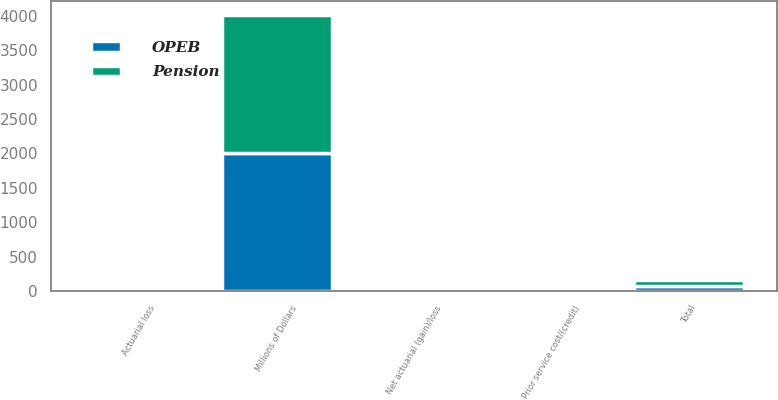Convert chart to OTSL. <chart><loc_0><loc_0><loc_500><loc_500><stacked_bar_chart><ecel><fcel>Millions of Dollars<fcel>Net actuarial (gain)/loss<fcel>Prior service cost/(credit)<fcel>Actuarial loss<fcel>Total<nl><fcel>Pension<fcel>2009<fcel>51<fcel>5<fcel>30<fcel>86<nl><fcel>OPEB<fcel>2009<fcel>21<fcel>44<fcel>12<fcel>67<nl></chart> 